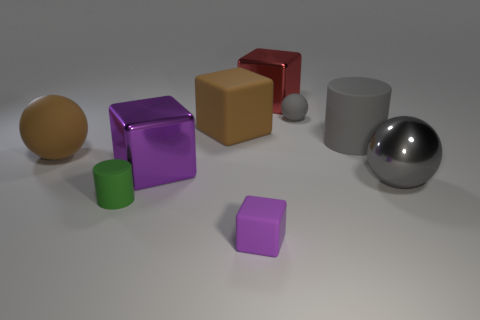Add 1 large red shiny cubes. How many objects exist? 10 Subtract all cylinders. How many objects are left? 7 Subtract 0 red spheres. How many objects are left? 9 Subtract all small objects. Subtract all rubber cubes. How many objects are left? 4 Add 9 big brown blocks. How many big brown blocks are left? 10 Add 5 large gray rubber cylinders. How many large gray rubber cylinders exist? 6 